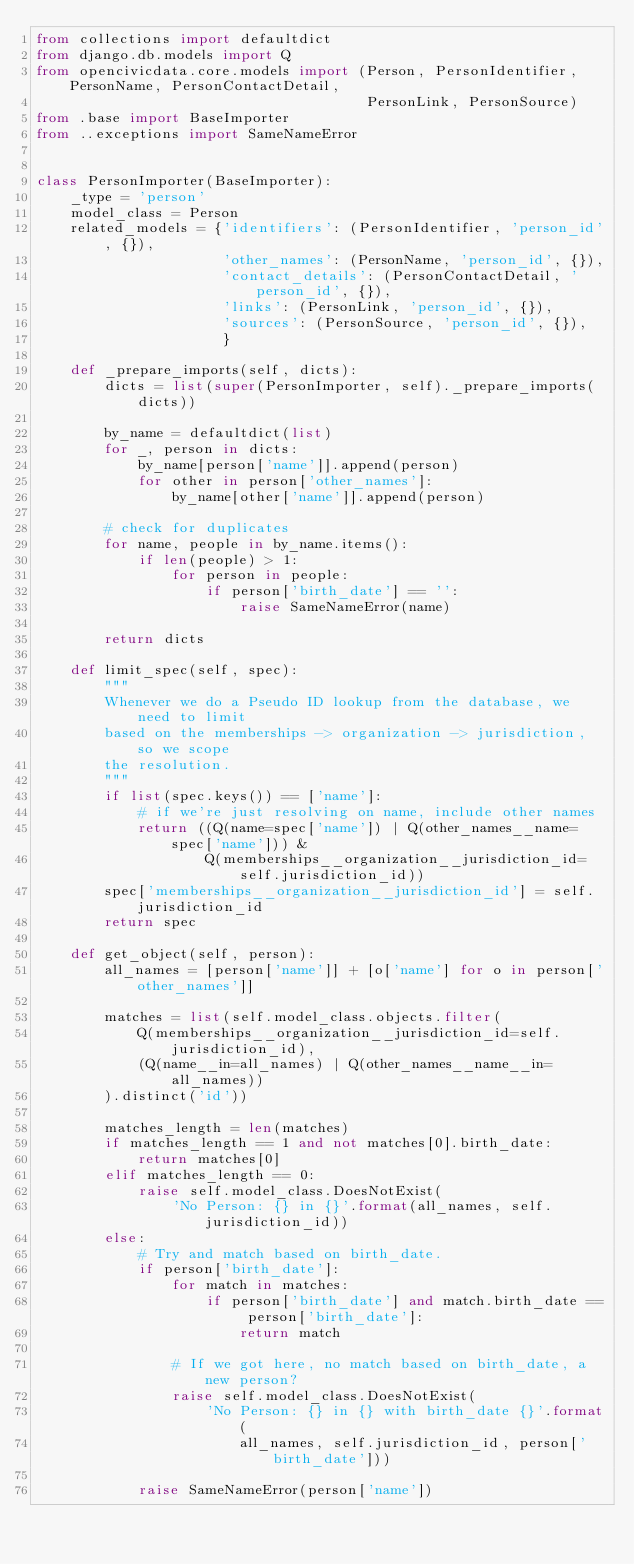Convert code to text. <code><loc_0><loc_0><loc_500><loc_500><_Python_>from collections import defaultdict
from django.db.models import Q
from opencivicdata.core.models import (Person, PersonIdentifier, PersonName, PersonContactDetail,
                                       PersonLink, PersonSource)
from .base import BaseImporter
from ..exceptions import SameNameError


class PersonImporter(BaseImporter):
    _type = 'person'
    model_class = Person
    related_models = {'identifiers': (PersonIdentifier, 'person_id', {}),
                      'other_names': (PersonName, 'person_id', {}),
                      'contact_details': (PersonContactDetail, 'person_id', {}),
                      'links': (PersonLink, 'person_id', {}),
                      'sources': (PersonSource, 'person_id', {}),
                      }

    def _prepare_imports(self, dicts):
        dicts = list(super(PersonImporter, self)._prepare_imports(dicts))

        by_name = defaultdict(list)
        for _, person in dicts:
            by_name[person['name']].append(person)
            for other in person['other_names']:
                by_name[other['name']].append(person)

        # check for duplicates
        for name, people in by_name.items():
            if len(people) > 1:
                for person in people:
                    if person['birth_date'] == '':
                        raise SameNameError(name)

        return dicts

    def limit_spec(self, spec):
        """
        Whenever we do a Pseudo ID lookup from the database, we need to limit
        based on the memberships -> organization -> jurisdiction, so we scope
        the resolution.
        """
        if list(spec.keys()) == ['name']:
            # if we're just resolving on name, include other names
            return ((Q(name=spec['name']) | Q(other_names__name=spec['name'])) &
                    Q(memberships__organization__jurisdiction_id=self.jurisdiction_id))
        spec['memberships__organization__jurisdiction_id'] = self.jurisdiction_id
        return spec

    def get_object(self, person):
        all_names = [person['name']] + [o['name'] for o in person['other_names']]

        matches = list(self.model_class.objects.filter(
            Q(memberships__organization__jurisdiction_id=self.jurisdiction_id),
            (Q(name__in=all_names) | Q(other_names__name__in=all_names))
        ).distinct('id'))

        matches_length = len(matches)
        if matches_length == 1 and not matches[0].birth_date:
            return matches[0]
        elif matches_length == 0:
            raise self.model_class.DoesNotExist(
                'No Person: {} in {}'.format(all_names, self.jurisdiction_id))
        else:
            # Try and match based on birth_date.
            if person['birth_date']:
                for match in matches:
                    if person['birth_date'] and match.birth_date == person['birth_date']:
                        return match

                # If we got here, no match based on birth_date, a new person?
                raise self.model_class.DoesNotExist(
                    'No Person: {} in {} with birth_date {}'.format(
                        all_names, self.jurisdiction_id, person['birth_date']))

            raise SameNameError(person['name'])
</code> 